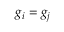Convert formula to latex. <formula><loc_0><loc_0><loc_500><loc_500>g _ { i } = g _ { j }</formula> 